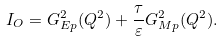Convert formula to latex. <formula><loc_0><loc_0><loc_500><loc_500>I _ { O } = G _ { E p } ^ { 2 } ( Q ^ { 2 } ) + \frac { \tau } { \varepsilon } G _ { M p } ^ { 2 } ( Q ^ { 2 } ) .</formula> 